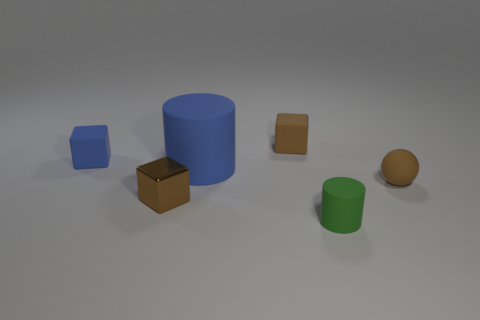Imagine these items are toys, what kind of game can you create using them? Using these objects as toys, one could create a sorting game where players must group the objects by shape or color within a time limit, or perhaps a stacking challenge to build the tallest stable structure without it toppling over. 